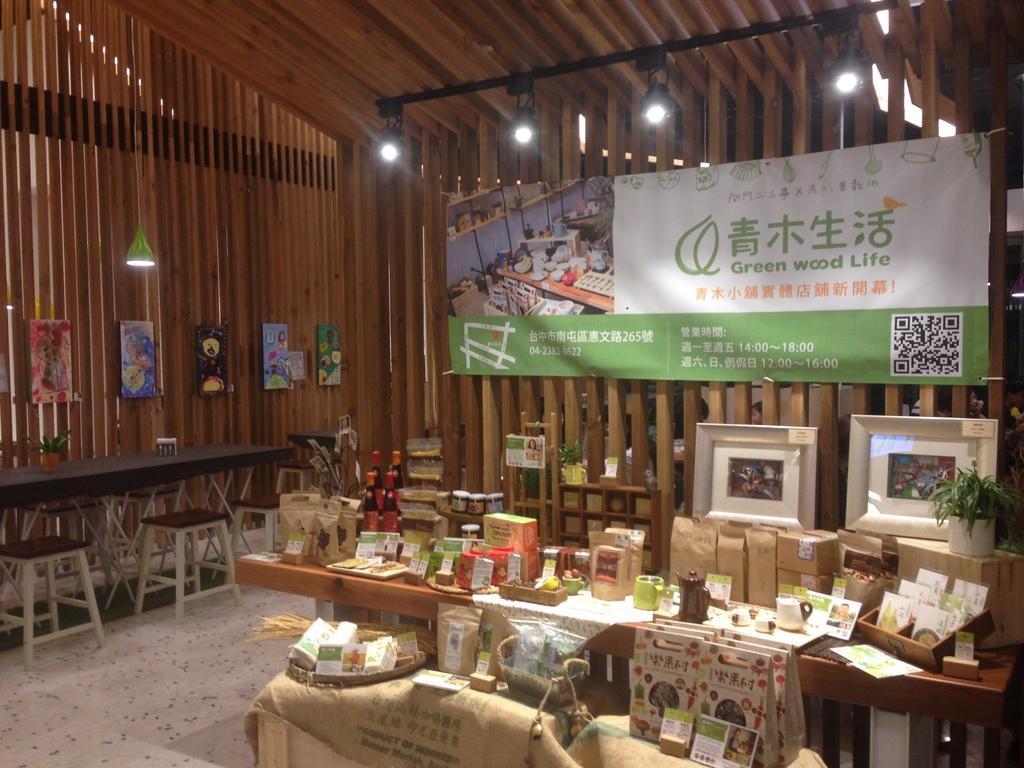Can you describe this image briefly? In this image in the front there are boxes and there are frames. On the left side there are stools and there is a plant and on the wall there are frames. In the background there is a banner with some text written on it and on the top there are lights and on the right side there is a plant. 